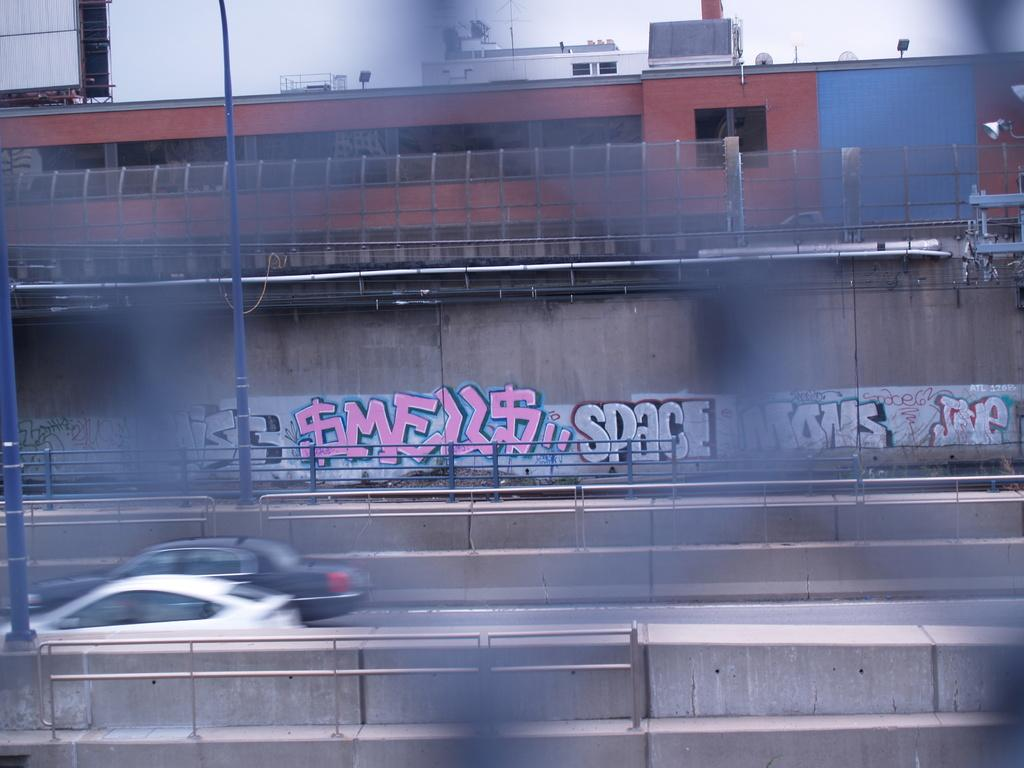<image>
Render a clear and concise summary of the photo. Car driving on a highway which says "SMELLS" on the wall. 